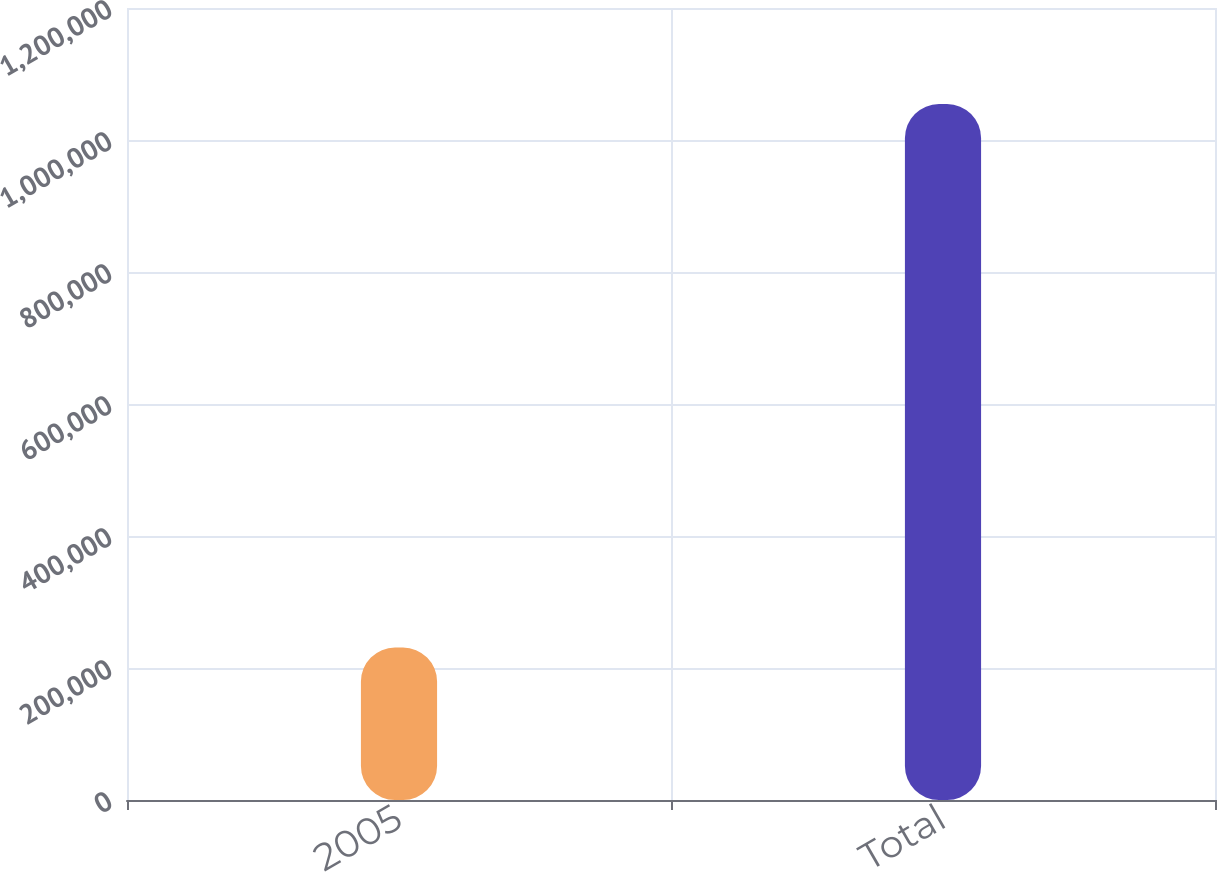<chart> <loc_0><loc_0><loc_500><loc_500><bar_chart><fcel>2005<fcel>Total<nl><fcel>231000<fcel>1.05442e+06<nl></chart> 